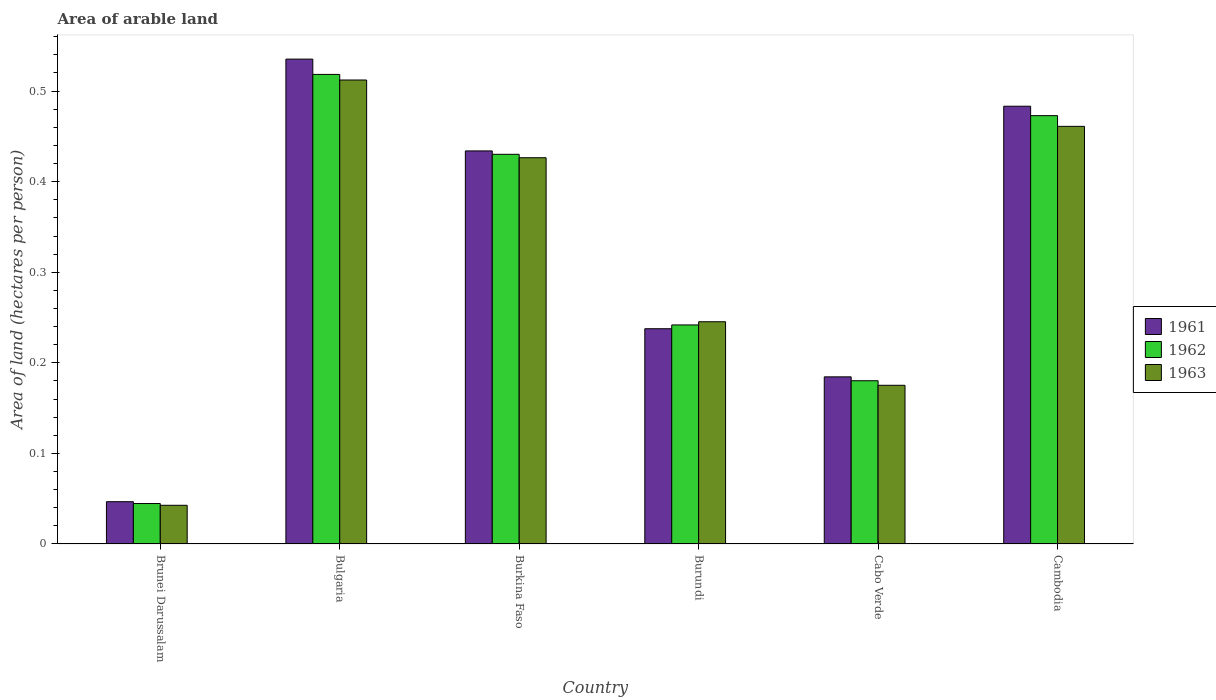How many different coloured bars are there?
Your answer should be very brief. 3. How many groups of bars are there?
Offer a very short reply. 6. Are the number of bars per tick equal to the number of legend labels?
Offer a very short reply. Yes. Are the number of bars on each tick of the X-axis equal?
Your response must be concise. Yes. How many bars are there on the 2nd tick from the left?
Offer a very short reply. 3. How many bars are there on the 6th tick from the right?
Make the answer very short. 3. What is the label of the 1st group of bars from the left?
Provide a short and direct response. Brunei Darussalam. In how many cases, is the number of bars for a given country not equal to the number of legend labels?
Provide a succinct answer. 0. What is the total arable land in 1962 in Cabo Verde?
Keep it short and to the point. 0.18. Across all countries, what is the maximum total arable land in 1963?
Your response must be concise. 0.51. Across all countries, what is the minimum total arable land in 1962?
Your answer should be compact. 0.04. In which country was the total arable land in 1961 maximum?
Offer a very short reply. Bulgaria. In which country was the total arable land in 1963 minimum?
Keep it short and to the point. Brunei Darussalam. What is the total total arable land in 1962 in the graph?
Your response must be concise. 1.89. What is the difference between the total arable land in 1962 in Bulgaria and that in Cambodia?
Offer a very short reply. 0.05. What is the difference between the total arable land in 1961 in Burkina Faso and the total arable land in 1962 in Cambodia?
Keep it short and to the point. -0.04. What is the average total arable land in 1961 per country?
Your answer should be very brief. 0.32. What is the difference between the total arable land of/in 1963 and total arable land of/in 1962 in Cabo Verde?
Your answer should be very brief. -0.01. In how many countries, is the total arable land in 1961 greater than 0.34 hectares per person?
Offer a terse response. 3. What is the ratio of the total arable land in 1961 in Bulgaria to that in Cambodia?
Your answer should be compact. 1.11. Is the total arable land in 1963 in Burkina Faso less than that in Cambodia?
Give a very brief answer. Yes. What is the difference between the highest and the second highest total arable land in 1961?
Give a very brief answer. 0.05. What is the difference between the highest and the lowest total arable land in 1962?
Your response must be concise. 0.47. In how many countries, is the total arable land in 1963 greater than the average total arable land in 1963 taken over all countries?
Your answer should be very brief. 3. Is the sum of the total arable land in 1961 in Bulgaria and Burundi greater than the maximum total arable land in 1963 across all countries?
Ensure brevity in your answer.  Yes. Are all the bars in the graph horizontal?
Your response must be concise. No. How many countries are there in the graph?
Your response must be concise. 6. What is the difference between two consecutive major ticks on the Y-axis?
Offer a terse response. 0.1. Are the values on the major ticks of Y-axis written in scientific E-notation?
Provide a short and direct response. No. Does the graph contain grids?
Offer a terse response. No. Where does the legend appear in the graph?
Make the answer very short. Center right. What is the title of the graph?
Provide a succinct answer. Area of arable land. What is the label or title of the Y-axis?
Keep it short and to the point. Area of land (hectares per person). What is the Area of land (hectares per person) of 1961 in Brunei Darussalam?
Provide a succinct answer. 0.05. What is the Area of land (hectares per person) of 1962 in Brunei Darussalam?
Your response must be concise. 0.04. What is the Area of land (hectares per person) in 1963 in Brunei Darussalam?
Your answer should be compact. 0.04. What is the Area of land (hectares per person) in 1961 in Bulgaria?
Ensure brevity in your answer.  0.54. What is the Area of land (hectares per person) in 1962 in Bulgaria?
Your response must be concise. 0.52. What is the Area of land (hectares per person) of 1963 in Bulgaria?
Give a very brief answer. 0.51. What is the Area of land (hectares per person) in 1961 in Burkina Faso?
Provide a short and direct response. 0.43. What is the Area of land (hectares per person) in 1962 in Burkina Faso?
Your answer should be compact. 0.43. What is the Area of land (hectares per person) in 1963 in Burkina Faso?
Offer a terse response. 0.43. What is the Area of land (hectares per person) in 1961 in Burundi?
Your answer should be compact. 0.24. What is the Area of land (hectares per person) of 1962 in Burundi?
Make the answer very short. 0.24. What is the Area of land (hectares per person) of 1963 in Burundi?
Your response must be concise. 0.25. What is the Area of land (hectares per person) in 1961 in Cabo Verde?
Provide a succinct answer. 0.18. What is the Area of land (hectares per person) in 1962 in Cabo Verde?
Offer a very short reply. 0.18. What is the Area of land (hectares per person) of 1963 in Cabo Verde?
Provide a succinct answer. 0.18. What is the Area of land (hectares per person) in 1961 in Cambodia?
Your answer should be compact. 0.48. What is the Area of land (hectares per person) in 1962 in Cambodia?
Make the answer very short. 0.47. What is the Area of land (hectares per person) in 1963 in Cambodia?
Your answer should be compact. 0.46. Across all countries, what is the maximum Area of land (hectares per person) in 1961?
Provide a succinct answer. 0.54. Across all countries, what is the maximum Area of land (hectares per person) in 1962?
Offer a terse response. 0.52. Across all countries, what is the maximum Area of land (hectares per person) of 1963?
Your answer should be compact. 0.51. Across all countries, what is the minimum Area of land (hectares per person) of 1961?
Provide a succinct answer. 0.05. Across all countries, what is the minimum Area of land (hectares per person) in 1962?
Provide a succinct answer. 0.04. Across all countries, what is the minimum Area of land (hectares per person) in 1963?
Keep it short and to the point. 0.04. What is the total Area of land (hectares per person) of 1961 in the graph?
Give a very brief answer. 1.92. What is the total Area of land (hectares per person) of 1962 in the graph?
Ensure brevity in your answer.  1.89. What is the total Area of land (hectares per person) of 1963 in the graph?
Offer a very short reply. 1.86. What is the difference between the Area of land (hectares per person) in 1961 in Brunei Darussalam and that in Bulgaria?
Your answer should be very brief. -0.49. What is the difference between the Area of land (hectares per person) in 1962 in Brunei Darussalam and that in Bulgaria?
Offer a terse response. -0.47. What is the difference between the Area of land (hectares per person) in 1963 in Brunei Darussalam and that in Bulgaria?
Ensure brevity in your answer.  -0.47. What is the difference between the Area of land (hectares per person) in 1961 in Brunei Darussalam and that in Burkina Faso?
Offer a very short reply. -0.39. What is the difference between the Area of land (hectares per person) of 1962 in Brunei Darussalam and that in Burkina Faso?
Provide a short and direct response. -0.39. What is the difference between the Area of land (hectares per person) in 1963 in Brunei Darussalam and that in Burkina Faso?
Give a very brief answer. -0.38. What is the difference between the Area of land (hectares per person) in 1961 in Brunei Darussalam and that in Burundi?
Offer a very short reply. -0.19. What is the difference between the Area of land (hectares per person) of 1962 in Brunei Darussalam and that in Burundi?
Your answer should be compact. -0.2. What is the difference between the Area of land (hectares per person) in 1963 in Brunei Darussalam and that in Burundi?
Provide a succinct answer. -0.2. What is the difference between the Area of land (hectares per person) of 1961 in Brunei Darussalam and that in Cabo Verde?
Give a very brief answer. -0.14. What is the difference between the Area of land (hectares per person) in 1962 in Brunei Darussalam and that in Cabo Verde?
Keep it short and to the point. -0.14. What is the difference between the Area of land (hectares per person) in 1963 in Brunei Darussalam and that in Cabo Verde?
Keep it short and to the point. -0.13. What is the difference between the Area of land (hectares per person) in 1961 in Brunei Darussalam and that in Cambodia?
Your response must be concise. -0.44. What is the difference between the Area of land (hectares per person) in 1962 in Brunei Darussalam and that in Cambodia?
Offer a terse response. -0.43. What is the difference between the Area of land (hectares per person) in 1963 in Brunei Darussalam and that in Cambodia?
Give a very brief answer. -0.42. What is the difference between the Area of land (hectares per person) of 1961 in Bulgaria and that in Burkina Faso?
Provide a short and direct response. 0.1. What is the difference between the Area of land (hectares per person) in 1962 in Bulgaria and that in Burkina Faso?
Keep it short and to the point. 0.09. What is the difference between the Area of land (hectares per person) in 1963 in Bulgaria and that in Burkina Faso?
Your response must be concise. 0.09. What is the difference between the Area of land (hectares per person) in 1961 in Bulgaria and that in Burundi?
Ensure brevity in your answer.  0.3. What is the difference between the Area of land (hectares per person) of 1962 in Bulgaria and that in Burundi?
Ensure brevity in your answer.  0.28. What is the difference between the Area of land (hectares per person) of 1963 in Bulgaria and that in Burundi?
Offer a very short reply. 0.27. What is the difference between the Area of land (hectares per person) in 1961 in Bulgaria and that in Cabo Verde?
Give a very brief answer. 0.35. What is the difference between the Area of land (hectares per person) of 1962 in Bulgaria and that in Cabo Verde?
Your answer should be very brief. 0.34. What is the difference between the Area of land (hectares per person) in 1963 in Bulgaria and that in Cabo Verde?
Provide a short and direct response. 0.34. What is the difference between the Area of land (hectares per person) of 1961 in Bulgaria and that in Cambodia?
Your response must be concise. 0.05. What is the difference between the Area of land (hectares per person) of 1962 in Bulgaria and that in Cambodia?
Give a very brief answer. 0.05. What is the difference between the Area of land (hectares per person) of 1963 in Bulgaria and that in Cambodia?
Your response must be concise. 0.05. What is the difference between the Area of land (hectares per person) of 1961 in Burkina Faso and that in Burundi?
Ensure brevity in your answer.  0.2. What is the difference between the Area of land (hectares per person) of 1962 in Burkina Faso and that in Burundi?
Offer a very short reply. 0.19. What is the difference between the Area of land (hectares per person) of 1963 in Burkina Faso and that in Burundi?
Offer a very short reply. 0.18. What is the difference between the Area of land (hectares per person) of 1961 in Burkina Faso and that in Cabo Verde?
Give a very brief answer. 0.25. What is the difference between the Area of land (hectares per person) of 1962 in Burkina Faso and that in Cabo Verde?
Offer a terse response. 0.25. What is the difference between the Area of land (hectares per person) in 1963 in Burkina Faso and that in Cabo Verde?
Provide a short and direct response. 0.25. What is the difference between the Area of land (hectares per person) in 1961 in Burkina Faso and that in Cambodia?
Ensure brevity in your answer.  -0.05. What is the difference between the Area of land (hectares per person) in 1962 in Burkina Faso and that in Cambodia?
Provide a succinct answer. -0.04. What is the difference between the Area of land (hectares per person) of 1963 in Burkina Faso and that in Cambodia?
Provide a succinct answer. -0.03. What is the difference between the Area of land (hectares per person) in 1961 in Burundi and that in Cabo Verde?
Your answer should be compact. 0.05. What is the difference between the Area of land (hectares per person) of 1962 in Burundi and that in Cabo Verde?
Provide a succinct answer. 0.06. What is the difference between the Area of land (hectares per person) in 1963 in Burundi and that in Cabo Verde?
Offer a terse response. 0.07. What is the difference between the Area of land (hectares per person) in 1961 in Burundi and that in Cambodia?
Provide a succinct answer. -0.25. What is the difference between the Area of land (hectares per person) in 1962 in Burundi and that in Cambodia?
Your response must be concise. -0.23. What is the difference between the Area of land (hectares per person) of 1963 in Burundi and that in Cambodia?
Ensure brevity in your answer.  -0.22. What is the difference between the Area of land (hectares per person) in 1961 in Cabo Verde and that in Cambodia?
Your answer should be compact. -0.3. What is the difference between the Area of land (hectares per person) in 1962 in Cabo Verde and that in Cambodia?
Provide a succinct answer. -0.29. What is the difference between the Area of land (hectares per person) of 1963 in Cabo Verde and that in Cambodia?
Provide a succinct answer. -0.29. What is the difference between the Area of land (hectares per person) of 1961 in Brunei Darussalam and the Area of land (hectares per person) of 1962 in Bulgaria?
Provide a succinct answer. -0.47. What is the difference between the Area of land (hectares per person) in 1961 in Brunei Darussalam and the Area of land (hectares per person) in 1963 in Bulgaria?
Ensure brevity in your answer.  -0.47. What is the difference between the Area of land (hectares per person) in 1962 in Brunei Darussalam and the Area of land (hectares per person) in 1963 in Bulgaria?
Your response must be concise. -0.47. What is the difference between the Area of land (hectares per person) of 1961 in Brunei Darussalam and the Area of land (hectares per person) of 1962 in Burkina Faso?
Give a very brief answer. -0.38. What is the difference between the Area of land (hectares per person) in 1961 in Brunei Darussalam and the Area of land (hectares per person) in 1963 in Burkina Faso?
Make the answer very short. -0.38. What is the difference between the Area of land (hectares per person) in 1962 in Brunei Darussalam and the Area of land (hectares per person) in 1963 in Burkina Faso?
Offer a very short reply. -0.38. What is the difference between the Area of land (hectares per person) in 1961 in Brunei Darussalam and the Area of land (hectares per person) in 1962 in Burundi?
Your answer should be very brief. -0.2. What is the difference between the Area of land (hectares per person) in 1961 in Brunei Darussalam and the Area of land (hectares per person) in 1963 in Burundi?
Make the answer very short. -0.2. What is the difference between the Area of land (hectares per person) of 1962 in Brunei Darussalam and the Area of land (hectares per person) of 1963 in Burundi?
Give a very brief answer. -0.2. What is the difference between the Area of land (hectares per person) of 1961 in Brunei Darussalam and the Area of land (hectares per person) of 1962 in Cabo Verde?
Your answer should be compact. -0.13. What is the difference between the Area of land (hectares per person) of 1961 in Brunei Darussalam and the Area of land (hectares per person) of 1963 in Cabo Verde?
Your answer should be compact. -0.13. What is the difference between the Area of land (hectares per person) in 1962 in Brunei Darussalam and the Area of land (hectares per person) in 1963 in Cabo Verde?
Keep it short and to the point. -0.13. What is the difference between the Area of land (hectares per person) of 1961 in Brunei Darussalam and the Area of land (hectares per person) of 1962 in Cambodia?
Give a very brief answer. -0.43. What is the difference between the Area of land (hectares per person) of 1961 in Brunei Darussalam and the Area of land (hectares per person) of 1963 in Cambodia?
Offer a very short reply. -0.41. What is the difference between the Area of land (hectares per person) of 1962 in Brunei Darussalam and the Area of land (hectares per person) of 1963 in Cambodia?
Your response must be concise. -0.42. What is the difference between the Area of land (hectares per person) of 1961 in Bulgaria and the Area of land (hectares per person) of 1962 in Burkina Faso?
Ensure brevity in your answer.  0.11. What is the difference between the Area of land (hectares per person) of 1961 in Bulgaria and the Area of land (hectares per person) of 1963 in Burkina Faso?
Offer a very short reply. 0.11. What is the difference between the Area of land (hectares per person) in 1962 in Bulgaria and the Area of land (hectares per person) in 1963 in Burkina Faso?
Offer a very short reply. 0.09. What is the difference between the Area of land (hectares per person) in 1961 in Bulgaria and the Area of land (hectares per person) in 1962 in Burundi?
Ensure brevity in your answer.  0.29. What is the difference between the Area of land (hectares per person) in 1961 in Bulgaria and the Area of land (hectares per person) in 1963 in Burundi?
Your response must be concise. 0.29. What is the difference between the Area of land (hectares per person) in 1962 in Bulgaria and the Area of land (hectares per person) in 1963 in Burundi?
Make the answer very short. 0.27. What is the difference between the Area of land (hectares per person) in 1961 in Bulgaria and the Area of land (hectares per person) in 1962 in Cabo Verde?
Offer a very short reply. 0.36. What is the difference between the Area of land (hectares per person) of 1961 in Bulgaria and the Area of land (hectares per person) of 1963 in Cabo Verde?
Your answer should be compact. 0.36. What is the difference between the Area of land (hectares per person) of 1962 in Bulgaria and the Area of land (hectares per person) of 1963 in Cabo Verde?
Your answer should be compact. 0.34. What is the difference between the Area of land (hectares per person) of 1961 in Bulgaria and the Area of land (hectares per person) of 1962 in Cambodia?
Your answer should be compact. 0.06. What is the difference between the Area of land (hectares per person) in 1961 in Bulgaria and the Area of land (hectares per person) in 1963 in Cambodia?
Make the answer very short. 0.07. What is the difference between the Area of land (hectares per person) of 1962 in Bulgaria and the Area of land (hectares per person) of 1963 in Cambodia?
Your answer should be compact. 0.06. What is the difference between the Area of land (hectares per person) in 1961 in Burkina Faso and the Area of land (hectares per person) in 1962 in Burundi?
Provide a short and direct response. 0.19. What is the difference between the Area of land (hectares per person) of 1961 in Burkina Faso and the Area of land (hectares per person) of 1963 in Burundi?
Provide a succinct answer. 0.19. What is the difference between the Area of land (hectares per person) of 1962 in Burkina Faso and the Area of land (hectares per person) of 1963 in Burundi?
Offer a very short reply. 0.18. What is the difference between the Area of land (hectares per person) of 1961 in Burkina Faso and the Area of land (hectares per person) of 1962 in Cabo Verde?
Provide a short and direct response. 0.25. What is the difference between the Area of land (hectares per person) of 1961 in Burkina Faso and the Area of land (hectares per person) of 1963 in Cabo Verde?
Ensure brevity in your answer.  0.26. What is the difference between the Area of land (hectares per person) of 1962 in Burkina Faso and the Area of land (hectares per person) of 1963 in Cabo Verde?
Your answer should be compact. 0.26. What is the difference between the Area of land (hectares per person) in 1961 in Burkina Faso and the Area of land (hectares per person) in 1962 in Cambodia?
Offer a terse response. -0.04. What is the difference between the Area of land (hectares per person) in 1961 in Burkina Faso and the Area of land (hectares per person) in 1963 in Cambodia?
Your answer should be compact. -0.03. What is the difference between the Area of land (hectares per person) in 1962 in Burkina Faso and the Area of land (hectares per person) in 1963 in Cambodia?
Offer a very short reply. -0.03. What is the difference between the Area of land (hectares per person) in 1961 in Burundi and the Area of land (hectares per person) in 1962 in Cabo Verde?
Keep it short and to the point. 0.06. What is the difference between the Area of land (hectares per person) in 1961 in Burundi and the Area of land (hectares per person) in 1963 in Cabo Verde?
Ensure brevity in your answer.  0.06. What is the difference between the Area of land (hectares per person) of 1962 in Burundi and the Area of land (hectares per person) of 1963 in Cabo Verde?
Your answer should be compact. 0.07. What is the difference between the Area of land (hectares per person) of 1961 in Burundi and the Area of land (hectares per person) of 1962 in Cambodia?
Keep it short and to the point. -0.24. What is the difference between the Area of land (hectares per person) of 1961 in Burundi and the Area of land (hectares per person) of 1963 in Cambodia?
Give a very brief answer. -0.22. What is the difference between the Area of land (hectares per person) of 1962 in Burundi and the Area of land (hectares per person) of 1963 in Cambodia?
Provide a short and direct response. -0.22. What is the difference between the Area of land (hectares per person) in 1961 in Cabo Verde and the Area of land (hectares per person) in 1962 in Cambodia?
Give a very brief answer. -0.29. What is the difference between the Area of land (hectares per person) of 1961 in Cabo Verde and the Area of land (hectares per person) of 1963 in Cambodia?
Make the answer very short. -0.28. What is the difference between the Area of land (hectares per person) of 1962 in Cabo Verde and the Area of land (hectares per person) of 1963 in Cambodia?
Offer a very short reply. -0.28. What is the average Area of land (hectares per person) in 1961 per country?
Keep it short and to the point. 0.32. What is the average Area of land (hectares per person) of 1962 per country?
Keep it short and to the point. 0.31. What is the average Area of land (hectares per person) in 1963 per country?
Offer a terse response. 0.31. What is the difference between the Area of land (hectares per person) in 1961 and Area of land (hectares per person) in 1962 in Brunei Darussalam?
Give a very brief answer. 0. What is the difference between the Area of land (hectares per person) of 1961 and Area of land (hectares per person) of 1963 in Brunei Darussalam?
Your answer should be very brief. 0. What is the difference between the Area of land (hectares per person) in 1962 and Area of land (hectares per person) in 1963 in Brunei Darussalam?
Offer a terse response. 0. What is the difference between the Area of land (hectares per person) of 1961 and Area of land (hectares per person) of 1962 in Bulgaria?
Make the answer very short. 0.02. What is the difference between the Area of land (hectares per person) in 1961 and Area of land (hectares per person) in 1963 in Bulgaria?
Offer a very short reply. 0.02. What is the difference between the Area of land (hectares per person) of 1962 and Area of land (hectares per person) of 1963 in Bulgaria?
Your answer should be very brief. 0.01. What is the difference between the Area of land (hectares per person) in 1961 and Area of land (hectares per person) in 1962 in Burkina Faso?
Your answer should be very brief. 0. What is the difference between the Area of land (hectares per person) of 1961 and Area of land (hectares per person) of 1963 in Burkina Faso?
Provide a succinct answer. 0.01. What is the difference between the Area of land (hectares per person) in 1962 and Area of land (hectares per person) in 1963 in Burkina Faso?
Your response must be concise. 0. What is the difference between the Area of land (hectares per person) of 1961 and Area of land (hectares per person) of 1962 in Burundi?
Offer a terse response. -0. What is the difference between the Area of land (hectares per person) in 1961 and Area of land (hectares per person) in 1963 in Burundi?
Provide a short and direct response. -0.01. What is the difference between the Area of land (hectares per person) of 1962 and Area of land (hectares per person) of 1963 in Burundi?
Offer a terse response. -0. What is the difference between the Area of land (hectares per person) in 1961 and Area of land (hectares per person) in 1962 in Cabo Verde?
Offer a very short reply. 0. What is the difference between the Area of land (hectares per person) of 1961 and Area of land (hectares per person) of 1963 in Cabo Verde?
Offer a very short reply. 0.01. What is the difference between the Area of land (hectares per person) of 1962 and Area of land (hectares per person) of 1963 in Cabo Verde?
Your answer should be very brief. 0.01. What is the difference between the Area of land (hectares per person) in 1961 and Area of land (hectares per person) in 1962 in Cambodia?
Keep it short and to the point. 0.01. What is the difference between the Area of land (hectares per person) in 1961 and Area of land (hectares per person) in 1963 in Cambodia?
Keep it short and to the point. 0.02. What is the difference between the Area of land (hectares per person) in 1962 and Area of land (hectares per person) in 1963 in Cambodia?
Provide a short and direct response. 0.01. What is the ratio of the Area of land (hectares per person) of 1961 in Brunei Darussalam to that in Bulgaria?
Provide a short and direct response. 0.09. What is the ratio of the Area of land (hectares per person) of 1962 in Brunei Darussalam to that in Bulgaria?
Offer a very short reply. 0.09. What is the ratio of the Area of land (hectares per person) of 1963 in Brunei Darussalam to that in Bulgaria?
Keep it short and to the point. 0.08. What is the ratio of the Area of land (hectares per person) in 1961 in Brunei Darussalam to that in Burkina Faso?
Your response must be concise. 0.11. What is the ratio of the Area of land (hectares per person) of 1962 in Brunei Darussalam to that in Burkina Faso?
Give a very brief answer. 0.1. What is the ratio of the Area of land (hectares per person) in 1963 in Brunei Darussalam to that in Burkina Faso?
Provide a short and direct response. 0.1. What is the ratio of the Area of land (hectares per person) in 1961 in Brunei Darussalam to that in Burundi?
Your answer should be very brief. 0.2. What is the ratio of the Area of land (hectares per person) of 1962 in Brunei Darussalam to that in Burundi?
Make the answer very short. 0.18. What is the ratio of the Area of land (hectares per person) of 1963 in Brunei Darussalam to that in Burundi?
Make the answer very short. 0.17. What is the ratio of the Area of land (hectares per person) in 1961 in Brunei Darussalam to that in Cabo Verde?
Offer a very short reply. 0.25. What is the ratio of the Area of land (hectares per person) in 1962 in Brunei Darussalam to that in Cabo Verde?
Provide a succinct answer. 0.25. What is the ratio of the Area of land (hectares per person) of 1963 in Brunei Darussalam to that in Cabo Verde?
Your answer should be compact. 0.24. What is the ratio of the Area of land (hectares per person) of 1961 in Brunei Darussalam to that in Cambodia?
Give a very brief answer. 0.1. What is the ratio of the Area of land (hectares per person) of 1962 in Brunei Darussalam to that in Cambodia?
Your response must be concise. 0.09. What is the ratio of the Area of land (hectares per person) of 1963 in Brunei Darussalam to that in Cambodia?
Offer a terse response. 0.09. What is the ratio of the Area of land (hectares per person) of 1961 in Bulgaria to that in Burkina Faso?
Ensure brevity in your answer.  1.23. What is the ratio of the Area of land (hectares per person) of 1962 in Bulgaria to that in Burkina Faso?
Provide a short and direct response. 1.21. What is the ratio of the Area of land (hectares per person) in 1963 in Bulgaria to that in Burkina Faso?
Offer a terse response. 1.2. What is the ratio of the Area of land (hectares per person) in 1961 in Bulgaria to that in Burundi?
Give a very brief answer. 2.25. What is the ratio of the Area of land (hectares per person) in 1962 in Bulgaria to that in Burundi?
Keep it short and to the point. 2.14. What is the ratio of the Area of land (hectares per person) in 1963 in Bulgaria to that in Burundi?
Offer a terse response. 2.09. What is the ratio of the Area of land (hectares per person) of 1961 in Bulgaria to that in Cabo Verde?
Offer a terse response. 2.9. What is the ratio of the Area of land (hectares per person) in 1962 in Bulgaria to that in Cabo Verde?
Offer a very short reply. 2.88. What is the ratio of the Area of land (hectares per person) in 1963 in Bulgaria to that in Cabo Verde?
Your answer should be compact. 2.92. What is the ratio of the Area of land (hectares per person) of 1961 in Bulgaria to that in Cambodia?
Give a very brief answer. 1.11. What is the ratio of the Area of land (hectares per person) of 1962 in Bulgaria to that in Cambodia?
Make the answer very short. 1.1. What is the ratio of the Area of land (hectares per person) in 1963 in Bulgaria to that in Cambodia?
Keep it short and to the point. 1.11. What is the ratio of the Area of land (hectares per person) of 1961 in Burkina Faso to that in Burundi?
Provide a short and direct response. 1.83. What is the ratio of the Area of land (hectares per person) of 1962 in Burkina Faso to that in Burundi?
Your answer should be compact. 1.78. What is the ratio of the Area of land (hectares per person) of 1963 in Burkina Faso to that in Burundi?
Provide a short and direct response. 1.74. What is the ratio of the Area of land (hectares per person) of 1961 in Burkina Faso to that in Cabo Verde?
Make the answer very short. 2.35. What is the ratio of the Area of land (hectares per person) in 1962 in Burkina Faso to that in Cabo Verde?
Make the answer very short. 2.39. What is the ratio of the Area of land (hectares per person) of 1963 in Burkina Faso to that in Cabo Verde?
Offer a terse response. 2.43. What is the ratio of the Area of land (hectares per person) in 1961 in Burkina Faso to that in Cambodia?
Keep it short and to the point. 0.9. What is the ratio of the Area of land (hectares per person) in 1962 in Burkina Faso to that in Cambodia?
Offer a terse response. 0.91. What is the ratio of the Area of land (hectares per person) in 1963 in Burkina Faso to that in Cambodia?
Offer a very short reply. 0.92. What is the ratio of the Area of land (hectares per person) of 1961 in Burundi to that in Cabo Verde?
Offer a very short reply. 1.29. What is the ratio of the Area of land (hectares per person) of 1962 in Burundi to that in Cabo Verde?
Offer a terse response. 1.34. What is the ratio of the Area of land (hectares per person) in 1963 in Burundi to that in Cabo Verde?
Your answer should be very brief. 1.4. What is the ratio of the Area of land (hectares per person) in 1961 in Burundi to that in Cambodia?
Your answer should be compact. 0.49. What is the ratio of the Area of land (hectares per person) of 1962 in Burundi to that in Cambodia?
Your answer should be very brief. 0.51. What is the ratio of the Area of land (hectares per person) in 1963 in Burundi to that in Cambodia?
Give a very brief answer. 0.53. What is the ratio of the Area of land (hectares per person) in 1961 in Cabo Verde to that in Cambodia?
Ensure brevity in your answer.  0.38. What is the ratio of the Area of land (hectares per person) of 1962 in Cabo Verde to that in Cambodia?
Offer a terse response. 0.38. What is the ratio of the Area of land (hectares per person) of 1963 in Cabo Verde to that in Cambodia?
Offer a very short reply. 0.38. What is the difference between the highest and the second highest Area of land (hectares per person) of 1961?
Your answer should be compact. 0.05. What is the difference between the highest and the second highest Area of land (hectares per person) of 1962?
Make the answer very short. 0.05. What is the difference between the highest and the second highest Area of land (hectares per person) in 1963?
Provide a short and direct response. 0.05. What is the difference between the highest and the lowest Area of land (hectares per person) in 1961?
Give a very brief answer. 0.49. What is the difference between the highest and the lowest Area of land (hectares per person) of 1962?
Offer a terse response. 0.47. What is the difference between the highest and the lowest Area of land (hectares per person) in 1963?
Provide a succinct answer. 0.47. 